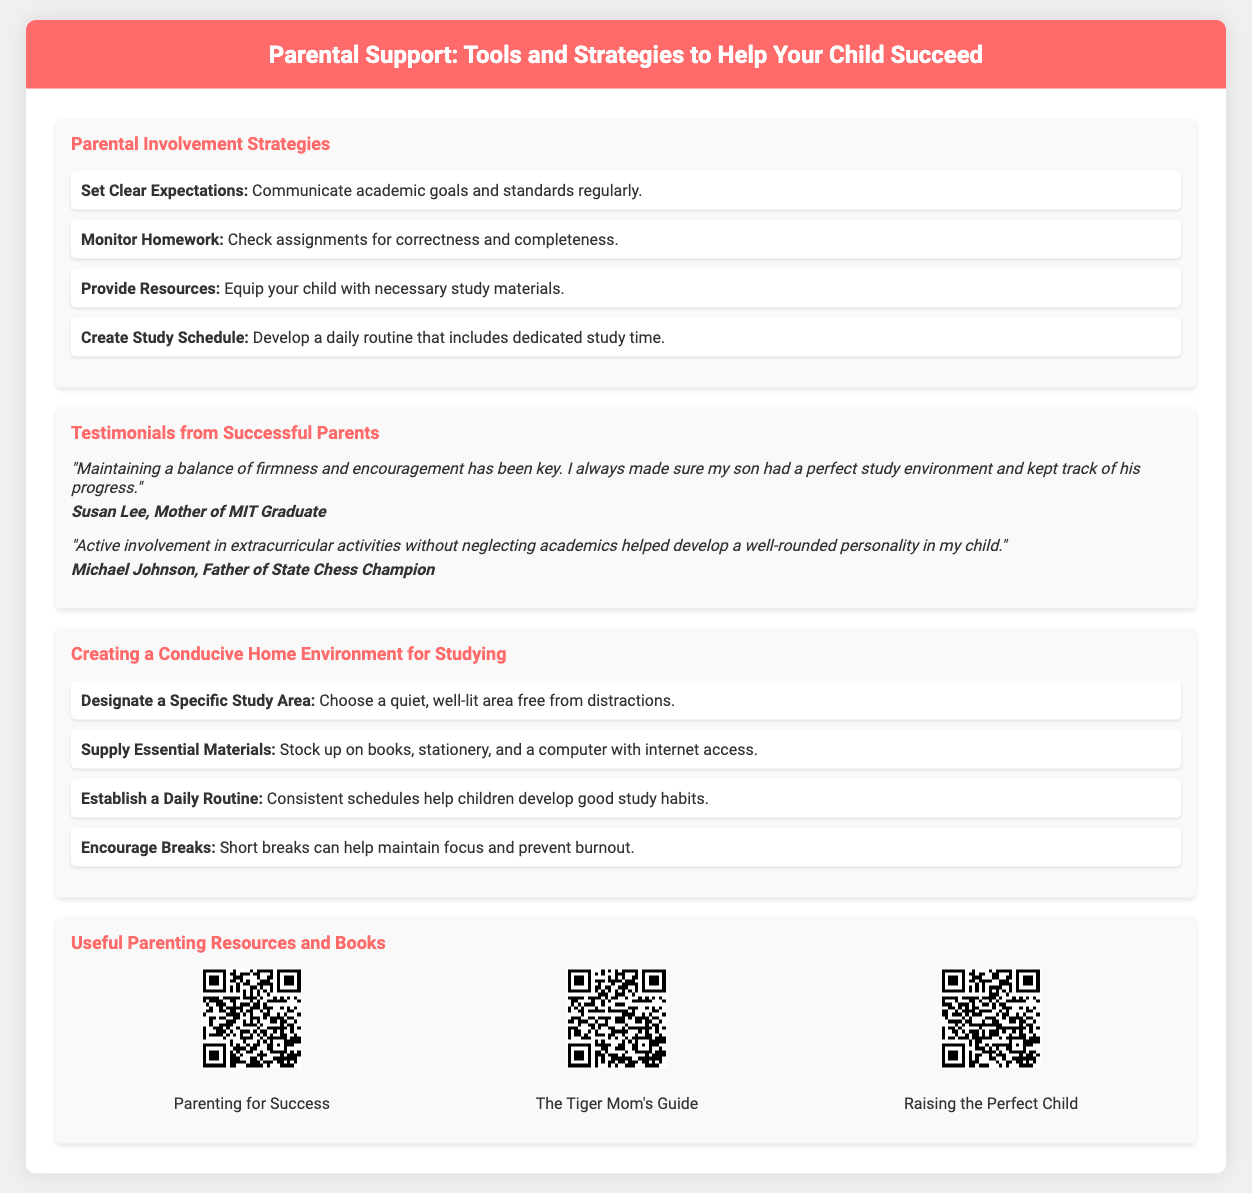What is the title of the presentation? The title of the presentation is prominently displayed at the top of the slide.
Answer: Parental Support: Tools and Strategies to Help Your Child Succeed How many parental involvement strategies are listed? The document outlines four specific parental involvement strategies in the flowchart section.
Answer: 4 Who is a mother of an MIT graduate mentioned in the testimonials? The testimonials include quotes from parents, one of whom is identified as the mother of an MIT graduate.
Answer: Susan Lee What is one recommended strategy for creating a conducive home environment? The infographic section suggests several strategies, one of which is highlighted for importance.
Answer: Designate a Specific Study Area What does the QR code for "The Tiger Mom's Guide" link to? The QR code section offers links to various resources, specifically labeled for each book.
Answer: The Tiger Mom's Guide 